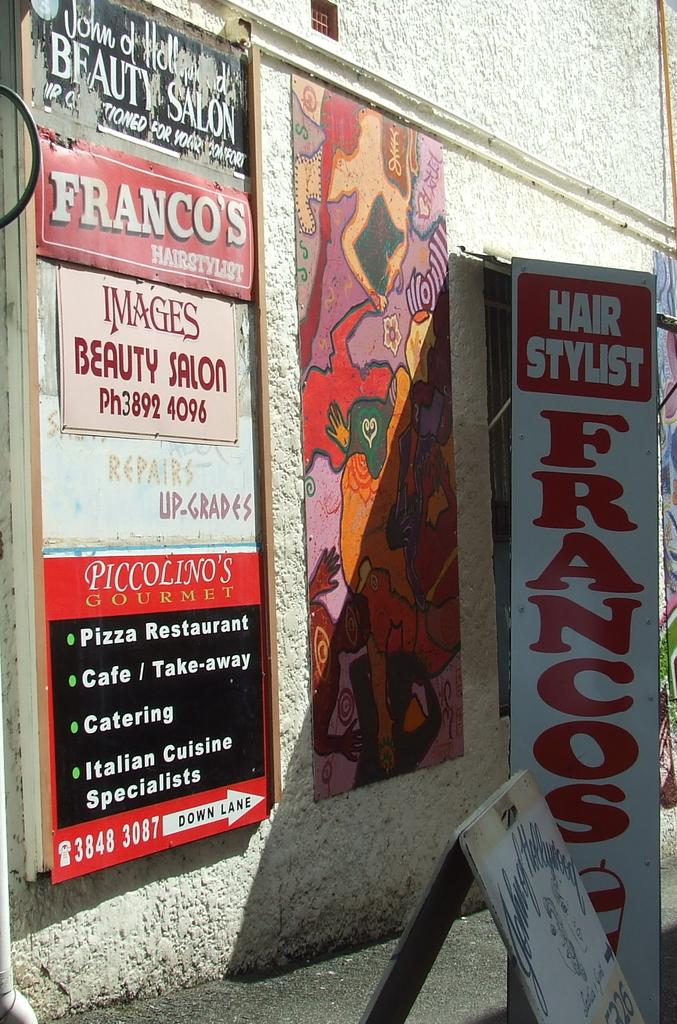<image>
Summarize the visual content of the image. A sign that says Hair Stylist Francos among other signs. 